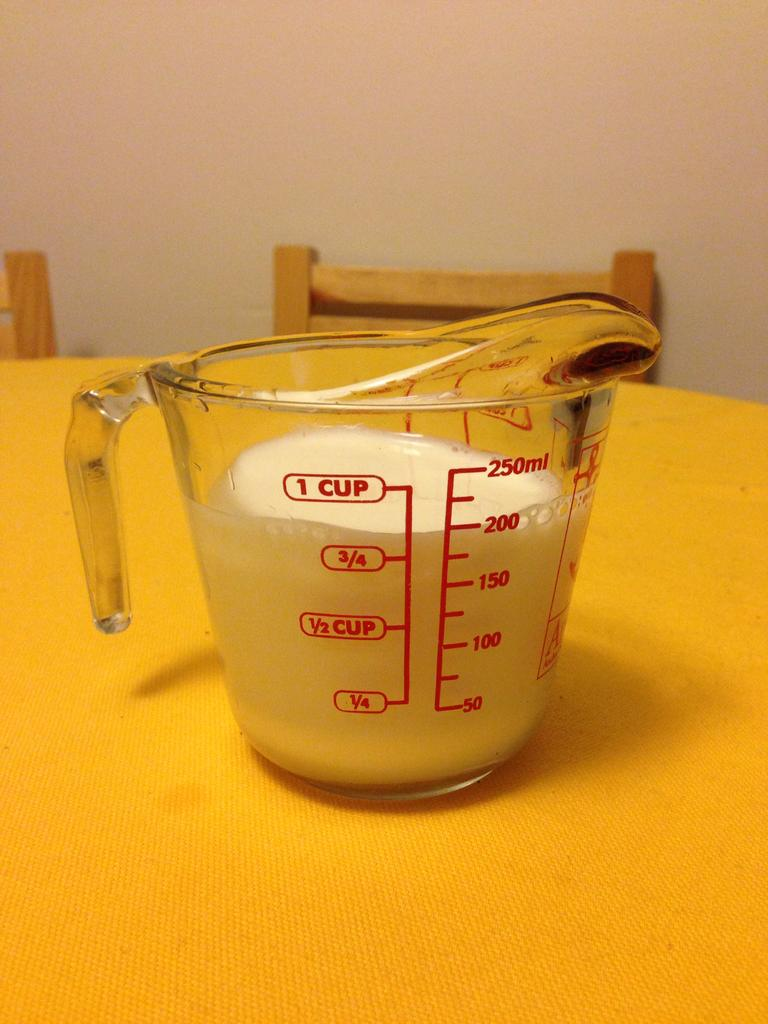<image>
Describe the image concisely. A measuring cup is filled to the 200 ml line with milk. 